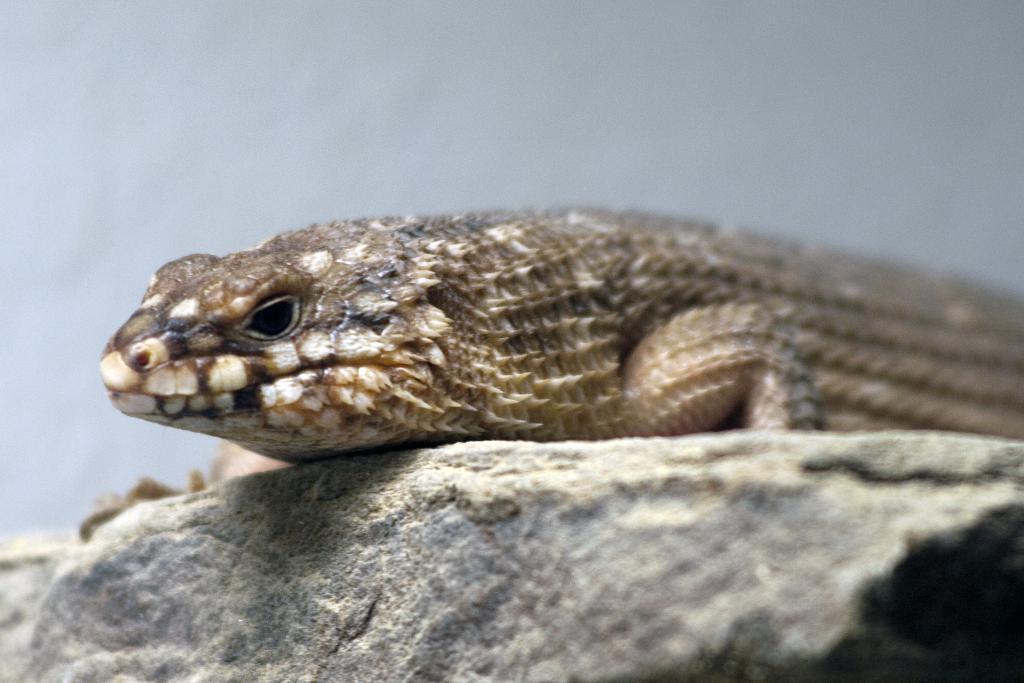How would you summarize this image in a sentence or two? In this picture, we see a reptile. At the bottom, we see the rock. In the background, it is white in color and it might be a wall. 